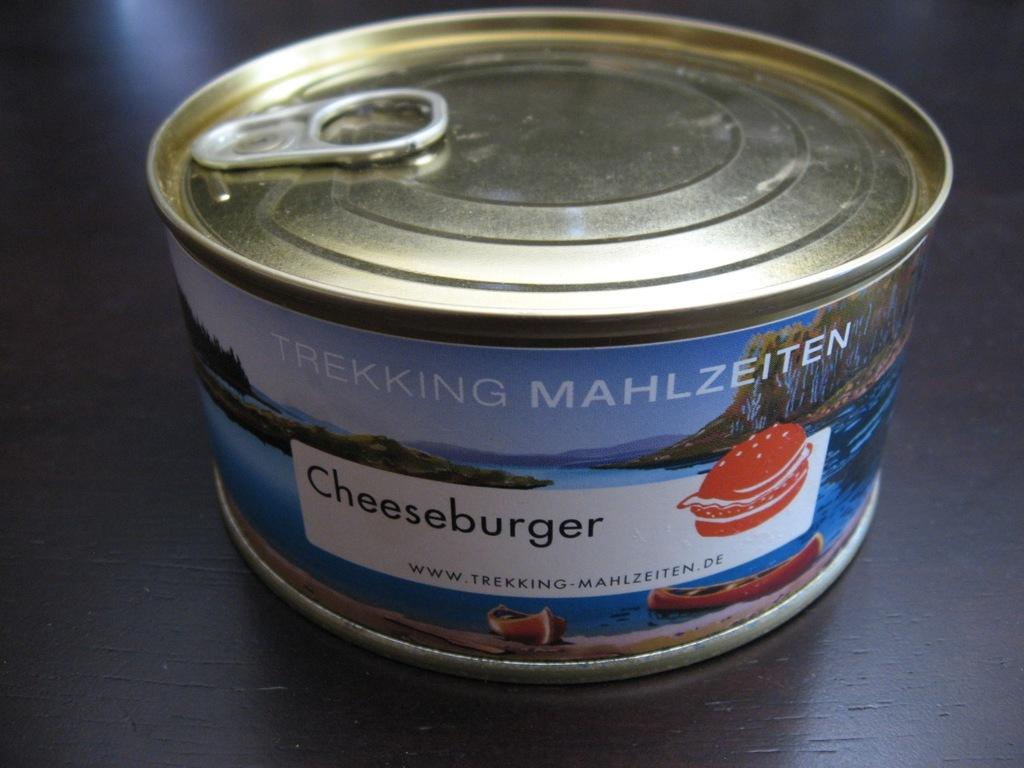<image>
Summarize the visual content of the image. A can of unopened cheeseburger sits on a dark wooden counter. 